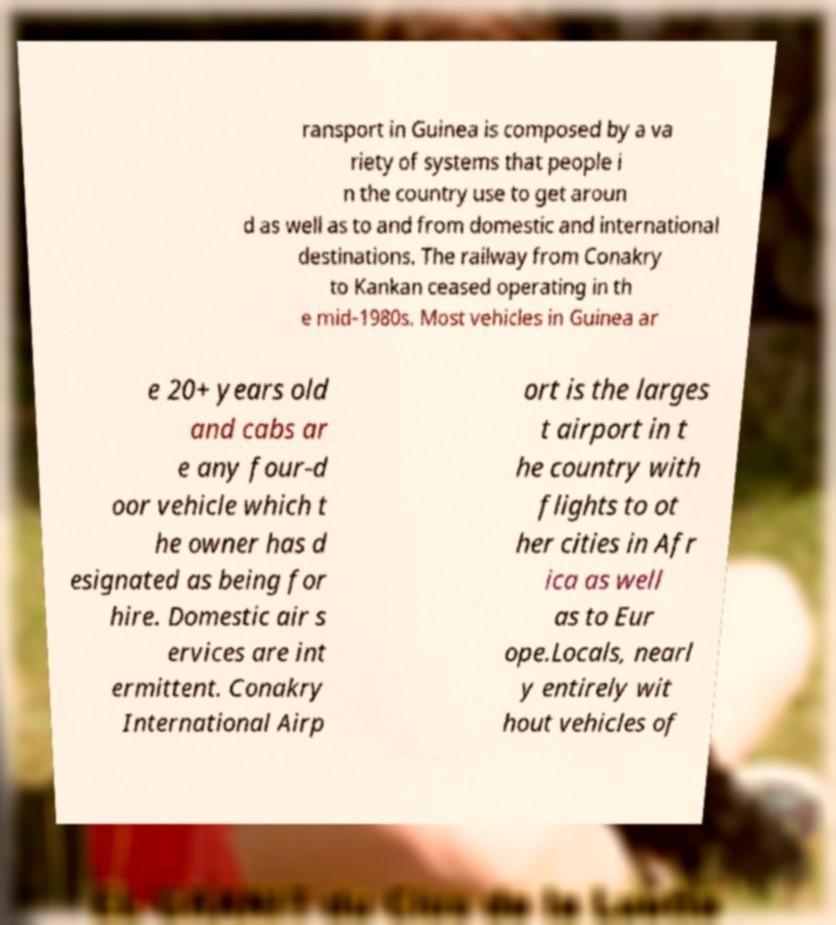What messages or text are displayed in this image? I need them in a readable, typed format. ransport in Guinea is composed by a va riety of systems that people i n the country use to get aroun d as well as to and from domestic and international destinations. The railway from Conakry to Kankan ceased operating in th e mid-1980s. Most vehicles in Guinea ar e 20+ years old and cabs ar e any four-d oor vehicle which t he owner has d esignated as being for hire. Domestic air s ervices are int ermittent. Conakry International Airp ort is the larges t airport in t he country with flights to ot her cities in Afr ica as well as to Eur ope.Locals, nearl y entirely wit hout vehicles of 